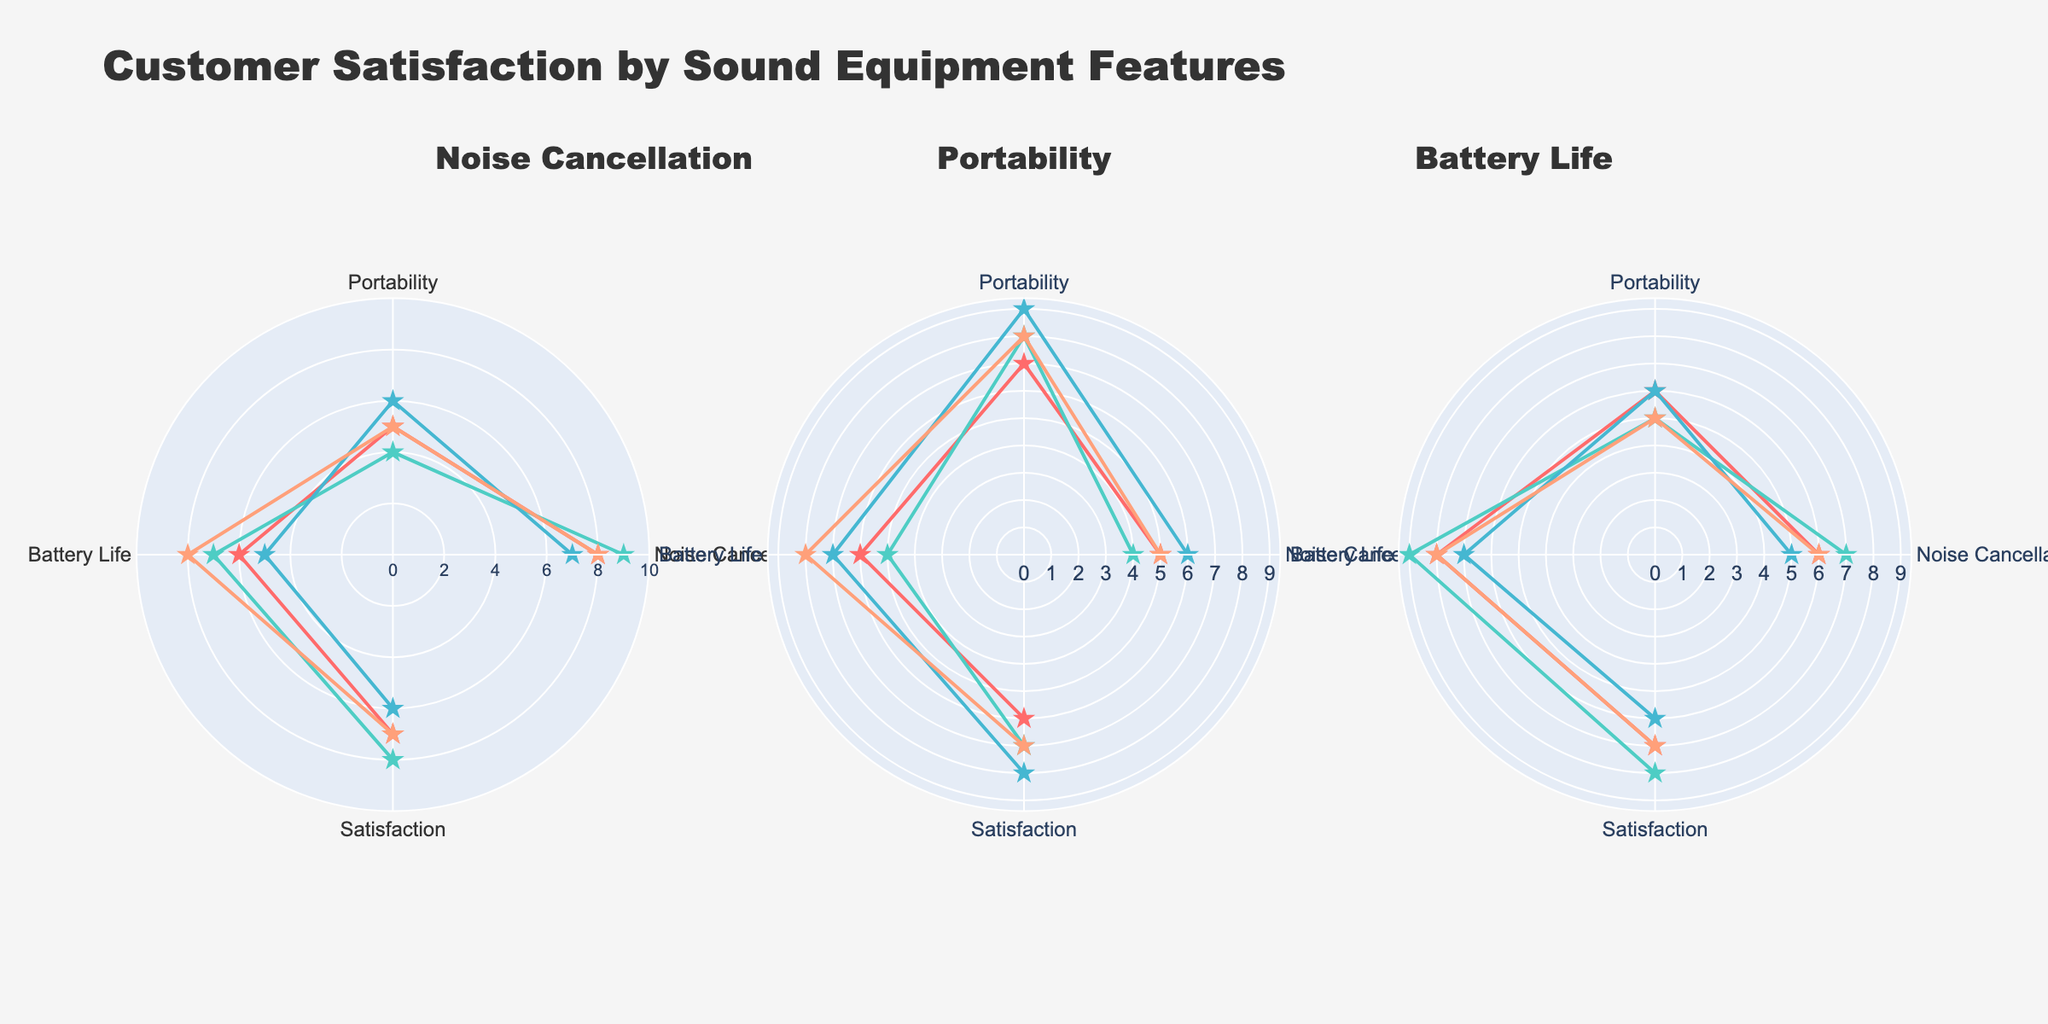What is the title of the figure? The title is typically displayed at the top of the chart in a prominent position. In this case, it should read "Customer Satisfaction by Sound Equipment Features."
Answer: Customer Satisfaction by Sound Equipment Features How many features are represented in the chart? By looking at the chart, you can see each subplot is titled by a feature. There are three distinct features: Noise Cancellation, Portability, and Battery Life.
Answer: 3 What is the radial axis range used in the figure? Radial axis defines the range of values plotted on the polar chart. The figure specifies a radial axis range from 0 to 10.
Answer: 0 to 10 Which customer has the highest satisfaction level for Noise Cancellation? By looking at the polar plot for Noise Cancellation, each customer is plotted with satisfaction levels. Customer 2 has the highest level of 8.
Answer: Customer 2 Which feature has the highest average satisfaction level across all customers? Calculate the average SatisfactionLevel for each feature: Noise Cancellation (7, 8, 6, 7 = 28/4 = 7), Portability (6, 7, 8, 7 = 28/4 = 7), Battery Life (7, 8, 6, 7 = 28/4 = 7). All features have the same average satisfaction level of 7.
Answer: All features Compare Customer 1's portability and battery life satisfaction levels. Which is higher? Customer 1's satisfaction level for Portability is 6, and for Battery Life it is 7. The Battery Life satisfaction level is higher.
Answer: Battery Life What are the satisfaction levels of Customer 3 across all features? Check Customer 3's values in each feature's subplot. Noise Cancellation: 6, Portability: 8, Battery Life: 6.
Answer: Noise Cancellation: 6, Portability: 8, Battery Life: 6 Which feature shows the most consistency in satisfaction levels among all customers? Consistency can be interpreted as having similar satisfaction levels across customers. Noise Cancellation: (7, 8, 6, 7), Portability: (6, 7, 8, 7), Battery Life: (7, 8, 6, 7). All features show similar consistency.
Answer: All features Which feature had the lowest average noise cancellation rating? Sum the NoiseCancellation scores for each feature and find the average: Noise Cancellation (8+9+7+8=32/4=8), Portability (5+4+6+5=20/4=5), Battery Life (6+7+5+6=24/4=6). Portability had the lowest average.
Answer: Portability 